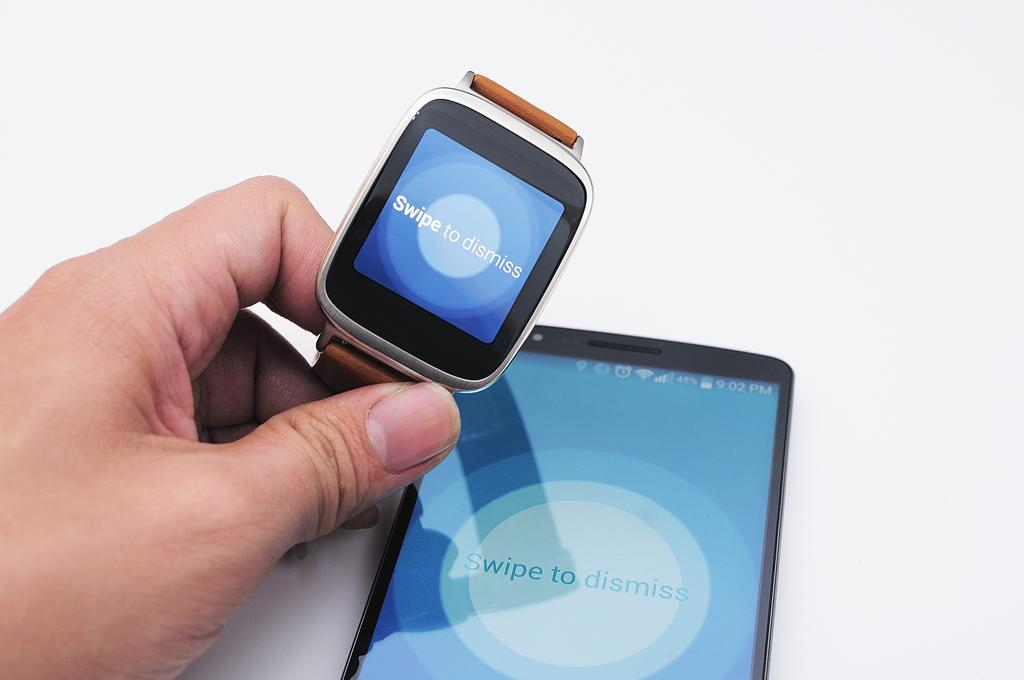Provide a one-sentence caption for the provided image. The watch and phone have a swipe to dismiss app. 